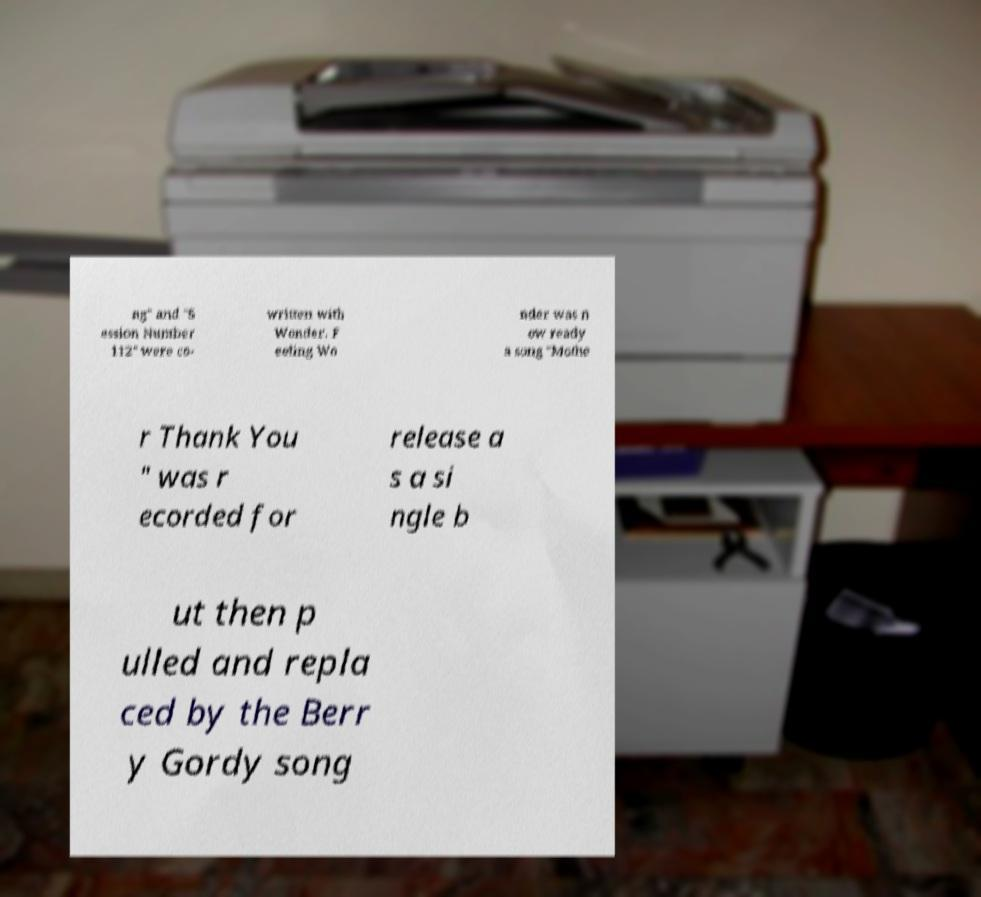Please read and relay the text visible in this image. What does it say? ng" and "S ession Number 112" were co- written with Wonder. F eeling Wo nder was n ow ready a song "Mothe r Thank You " was r ecorded for release a s a si ngle b ut then p ulled and repla ced by the Berr y Gordy song 